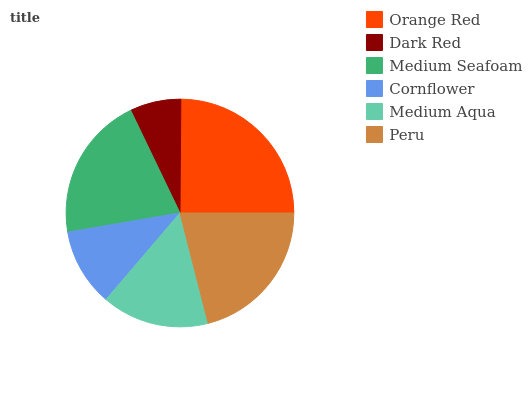Is Dark Red the minimum?
Answer yes or no. Yes. Is Orange Red the maximum?
Answer yes or no. Yes. Is Medium Seafoam the minimum?
Answer yes or no. No. Is Medium Seafoam the maximum?
Answer yes or no. No. Is Medium Seafoam greater than Dark Red?
Answer yes or no. Yes. Is Dark Red less than Medium Seafoam?
Answer yes or no. Yes. Is Dark Red greater than Medium Seafoam?
Answer yes or no. No. Is Medium Seafoam less than Dark Red?
Answer yes or no. No. Is Medium Seafoam the high median?
Answer yes or no. Yes. Is Medium Aqua the low median?
Answer yes or no. Yes. Is Peru the high median?
Answer yes or no. No. Is Orange Red the low median?
Answer yes or no. No. 